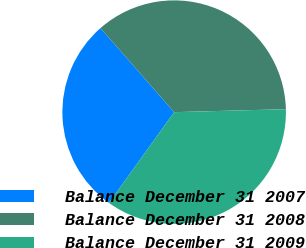Convert chart to OTSL. <chart><loc_0><loc_0><loc_500><loc_500><pie_chart><fcel>Balance December 31 2007<fcel>Balance December 31 2008<fcel>Balance December 31 2009<nl><fcel>28.63%<fcel>36.04%<fcel>35.33%<nl></chart> 